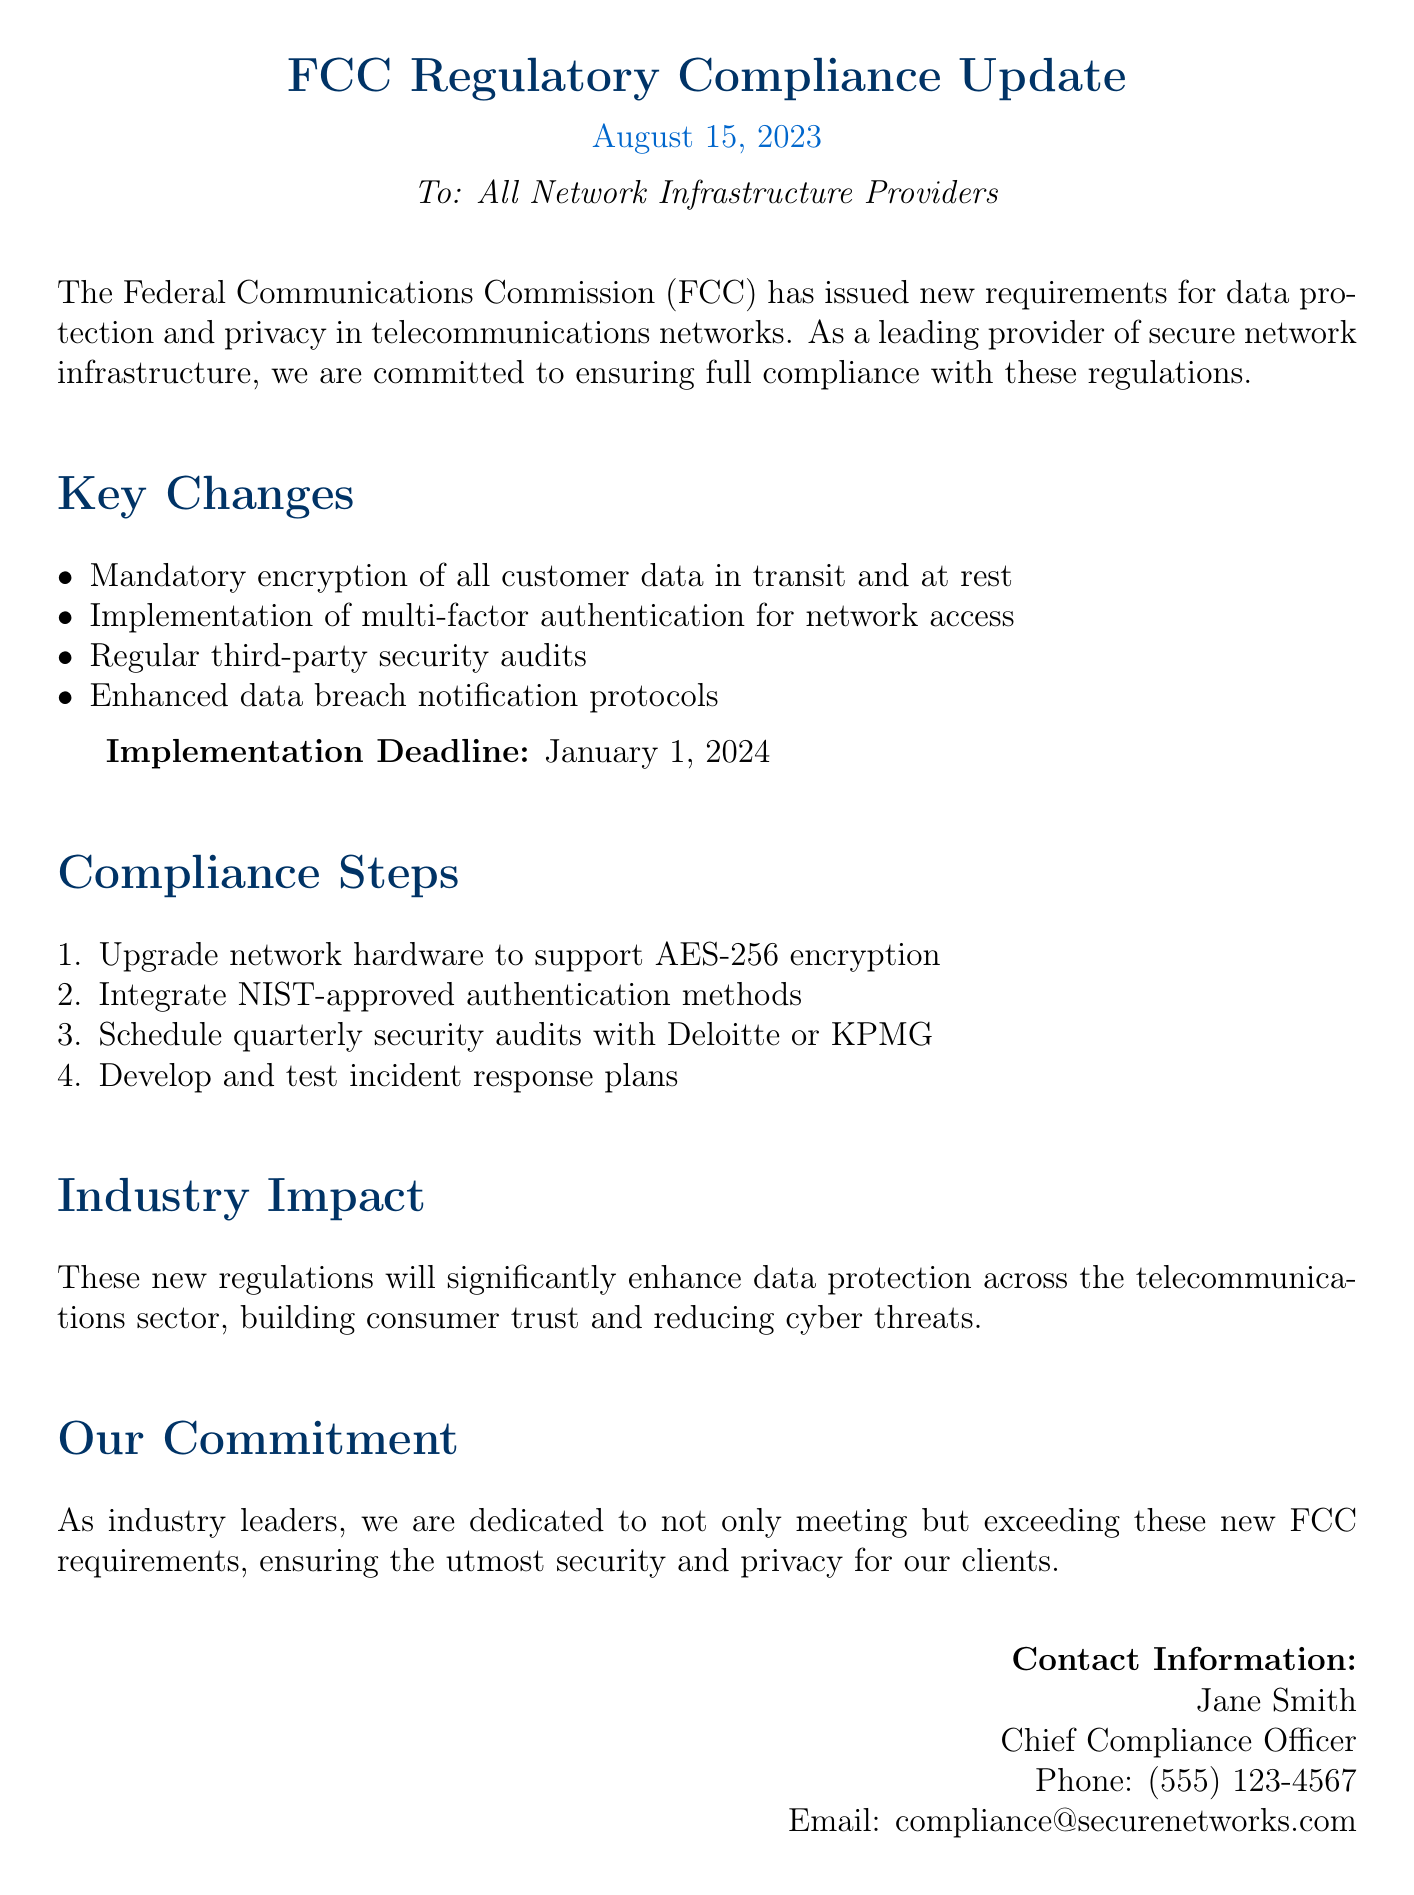What is the date of the FCC Regulatory Compliance Update? The document states the date of the update as August 15, 2023.
Answer: August 15, 2023 Who is the Chief Compliance Officer? The document identifies Jane Smith as the Chief Compliance Officer.
Answer: Jane Smith What is the implementation deadline for the new requirements? The document specifies the implementation deadline as January 1, 2024.
Answer: January 1, 2024 What type of encryption is mandated for customer data? The document mentions mandatory encryption of all customer data using AES-256.
Answer: AES-256 What will the quarterly security audits be scheduled with? The document lists Deloitte or KPMG as the firms for quarterly security audits.
Answer: Deloitte or KPMG Why are these new regulations important for the telecommunications sector? The document explains that these regulations will enhance data protection, build consumer trust, and reduce cyber threats.
Answer: Enhance data protection, build consumer trust, and reduce cyber threats What is the first compliance step outlined in the document? The document lists upgrading network hardware to support AES-256 encryption as the first compliance step.
Answer: Upgrade network hardware to support AES-256 encryption How will consumer trust be affected by these regulations? The document states that the new regulations will build consumer trust.
Answer: Build consumer trust 